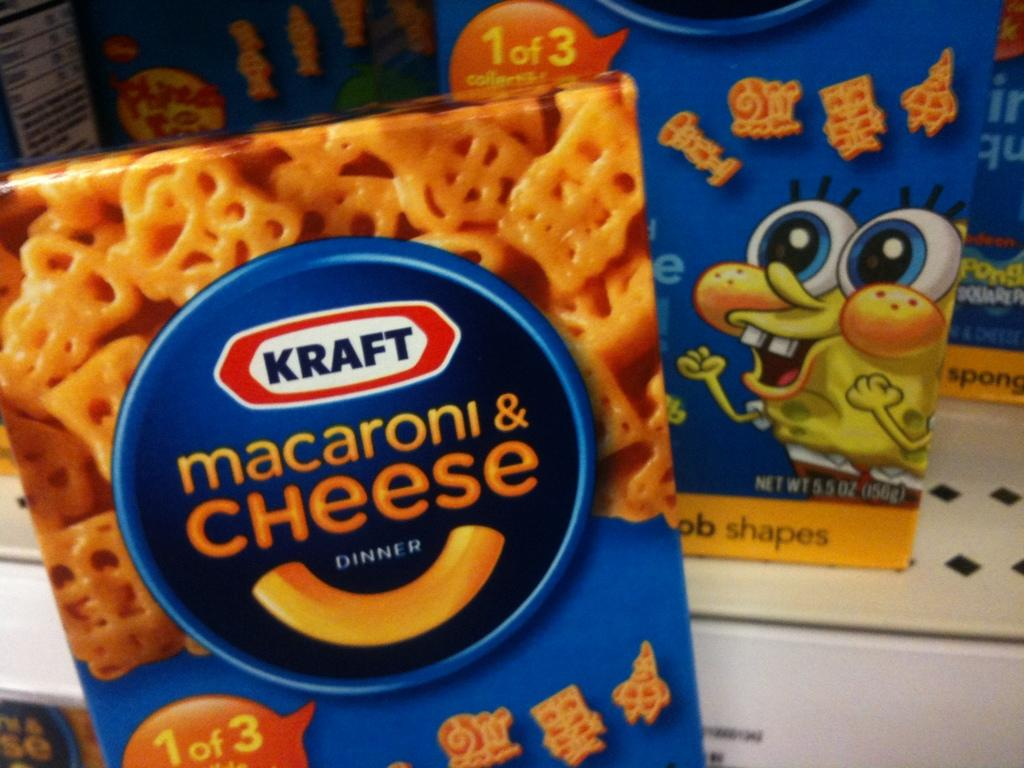What color are the boxes in the image? The boxes in the image are blue colored. Where are the boxes located? The boxes are placed on a table. What can be seen on the surface of the boxes? There is text visible on the boxes. How many beans are falling from the boxes in the image? There are no beans present in the image, and therefore no beans are falling from the boxes. 